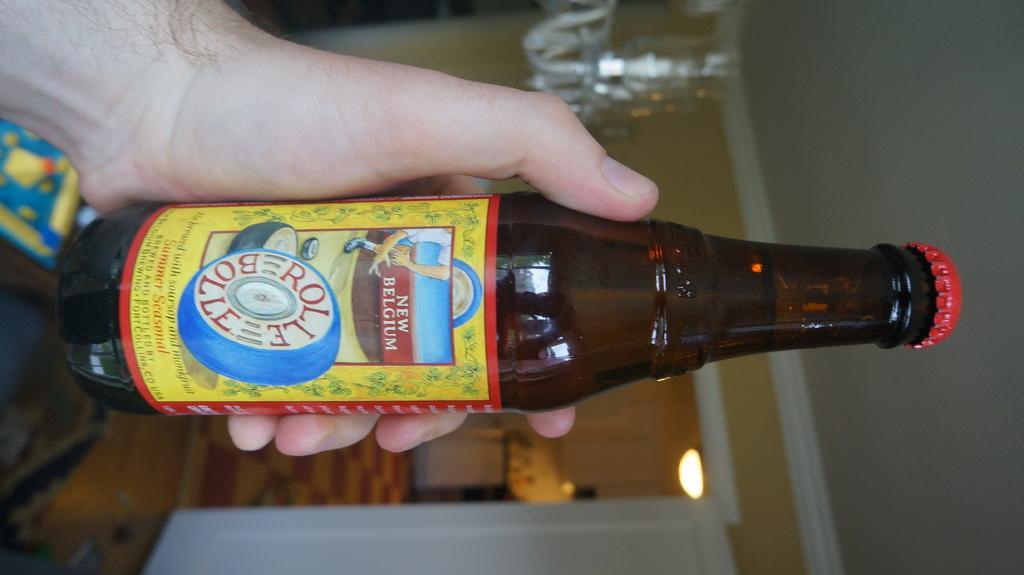In one or two sentences, can you explain what this image depicts? In this image I can see a person is holding a bottle and sticker is attached to it. Back I can see door, light and the wall. 